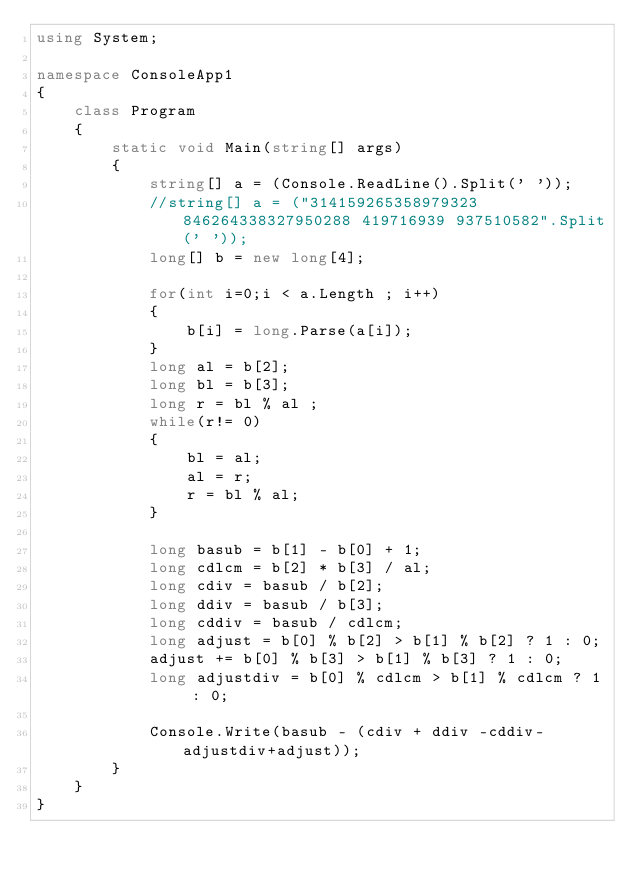<code> <loc_0><loc_0><loc_500><loc_500><_C#_>using System;

namespace ConsoleApp1
{
    class Program
    {
        static void Main(string[] args)
        {
            string[] a = (Console.ReadLine().Split(' '));
            //string[] a = ("314159265358979323 846264338327950288 419716939 937510582".Split(' '));
            long[] b = new long[4];

            for(int i=0;i < a.Length ; i++)
            {
                b[i] = long.Parse(a[i]);
            }
            long al = b[2];
            long bl = b[3];
            long r = bl % al ;
            while(r!= 0)
            {
                bl = al;
                al = r;
                r = bl % al;
            }

            long basub = b[1] - b[0] + 1;
            long cdlcm = b[2] * b[3] / al;
            long cdiv = basub / b[2];
            long ddiv = basub / b[3];
            long cddiv = basub / cdlcm;
            long adjust = b[0] % b[2] > b[1] % b[2] ? 1 : 0;
            adjust += b[0] % b[3] > b[1] % b[3] ? 1 : 0;
            long adjustdiv = b[0] % cdlcm > b[1] % cdlcm ? 1 : 0;

            Console.Write(basub - (cdiv + ddiv -cddiv-adjustdiv+adjust));
        }
    }
}
</code> 